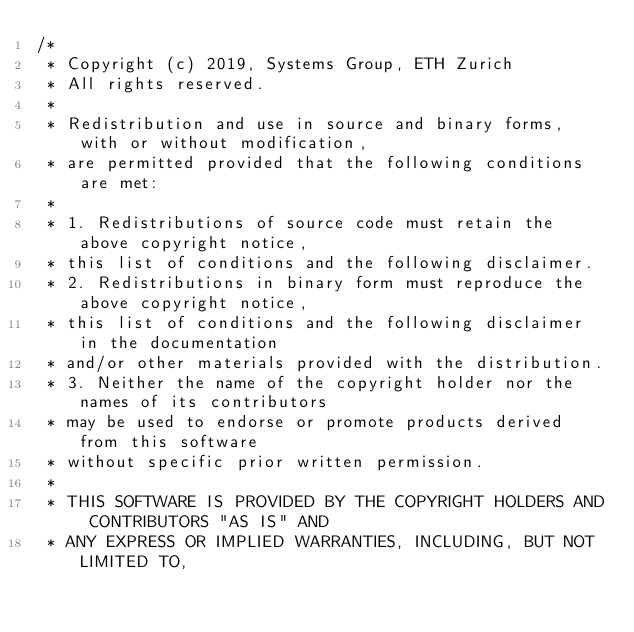Convert code to text. <code><loc_0><loc_0><loc_500><loc_500><_C++_>/*
 * Copyright (c) 2019, Systems Group, ETH Zurich
 * All rights reserved.
 *
 * Redistribution and use in source and binary forms, with or without modification,
 * are permitted provided that the following conditions are met:
 *
 * 1. Redistributions of source code must retain the above copyright notice,
 * this list of conditions and the following disclaimer.
 * 2. Redistributions in binary form must reproduce the above copyright notice,
 * this list of conditions and the following disclaimer in the documentation
 * and/or other materials provided with the distribution.
 * 3. Neither the name of the copyright holder nor the names of its contributors
 * may be used to endorse or promote products derived from this software
 * without specific prior written permission.
 *
 * THIS SOFTWARE IS PROVIDED BY THE COPYRIGHT HOLDERS AND CONTRIBUTORS "AS IS" AND
 * ANY EXPRESS OR IMPLIED WARRANTIES, INCLUDING, BUT NOT LIMITED TO,</code> 